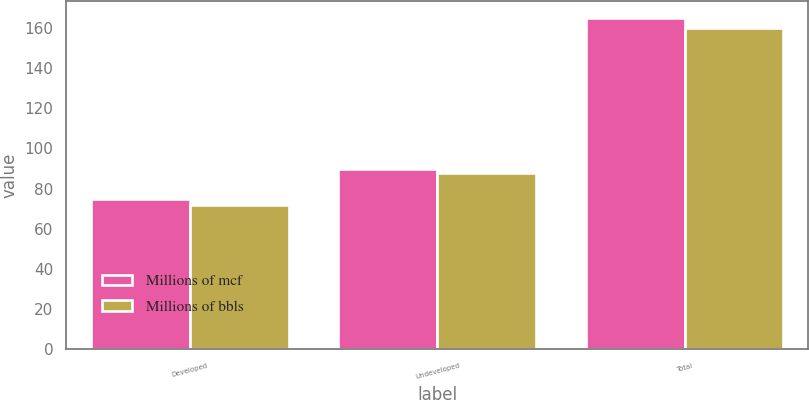<chart> <loc_0><loc_0><loc_500><loc_500><stacked_bar_chart><ecel><fcel>Developed<fcel>Undeveloped<fcel>Total<nl><fcel>Millions of mcf<fcel>75<fcel>90<fcel>165<nl><fcel>Millions of bbls<fcel>72<fcel>88<fcel>160<nl></chart> 